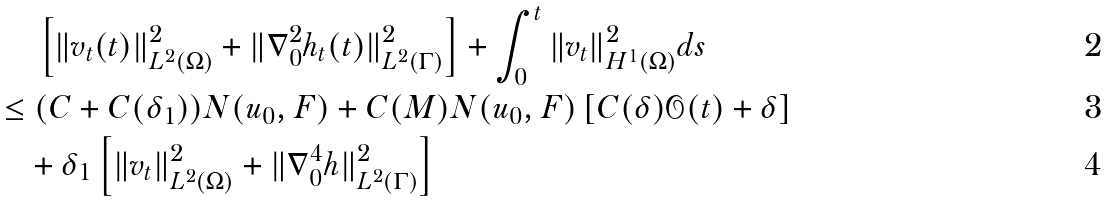Convert formula to latex. <formula><loc_0><loc_0><loc_500><loc_500>& \ \left [ \| v _ { t } ( t ) \| ^ { 2 } _ { L ^ { 2 } ( \Omega ) } + \| \nabla _ { 0 } ^ { 2 } h _ { t } ( t ) \| ^ { 2 } _ { L ^ { 2 } ( \Gamma ) } \right ] + \int _ { 0 } ^ { t } \| v _ { t } \| ^ { 2 } _ { H ^ { 1 } ( \Omega ) } d s \\ \leq & \ ( C + C ( \delta _ { 1 } ) ) N ( u _ { 0 } , F ) + C ( M ) N ( u _ { 0 } , F ) \left [ C ( \delta ) { \mathcal { O } } ( t ) + \delta \right ] \\ & + \delta _ { 1 } \left [ \| v _ { t } \| ^ { 2 } _ { L ^ { 2 } ( \Omega ) } + \| \nabla _ { 0 } ^ { 4 } h \| ^ { 2 } _ { L ^ { 2 } ( \Gamma ) } \right ]</formula> 